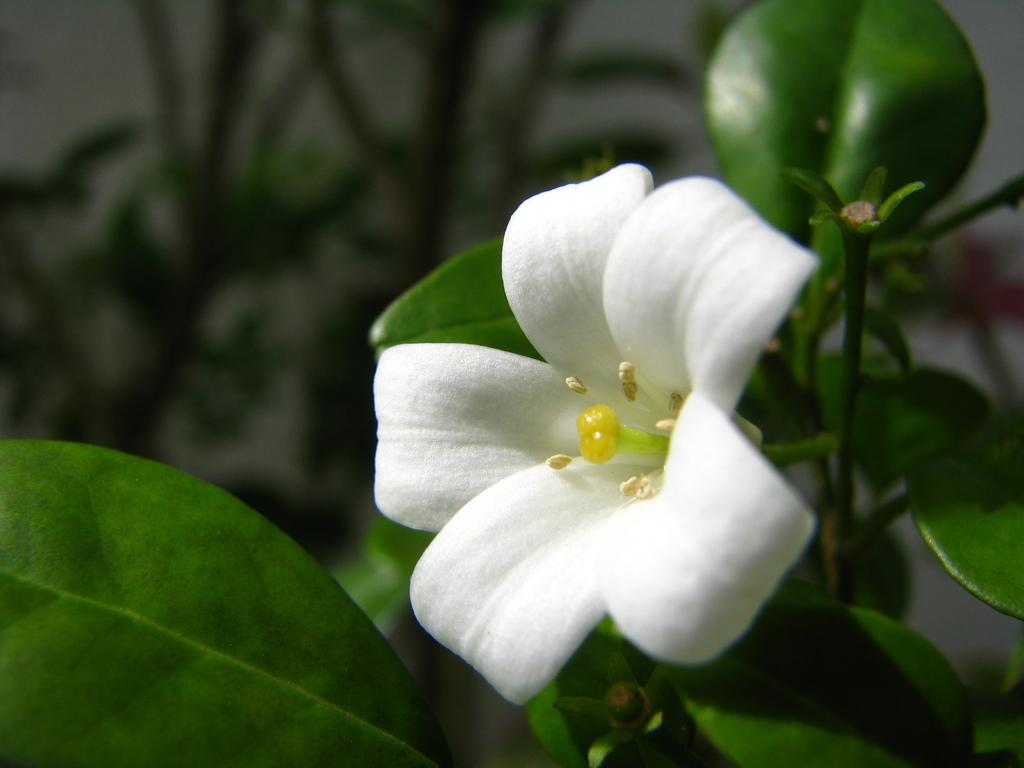What is the main subject in the foreground of the image? There is a white flower on a plant in the foreground of the image. Can you describe the background of the image? The background of the image is blurred. Is there a doctor examining the ladybug on the plant in the image? There is no doctor or ladybug present in the image; it features a white flower on a plant in the foreground. 